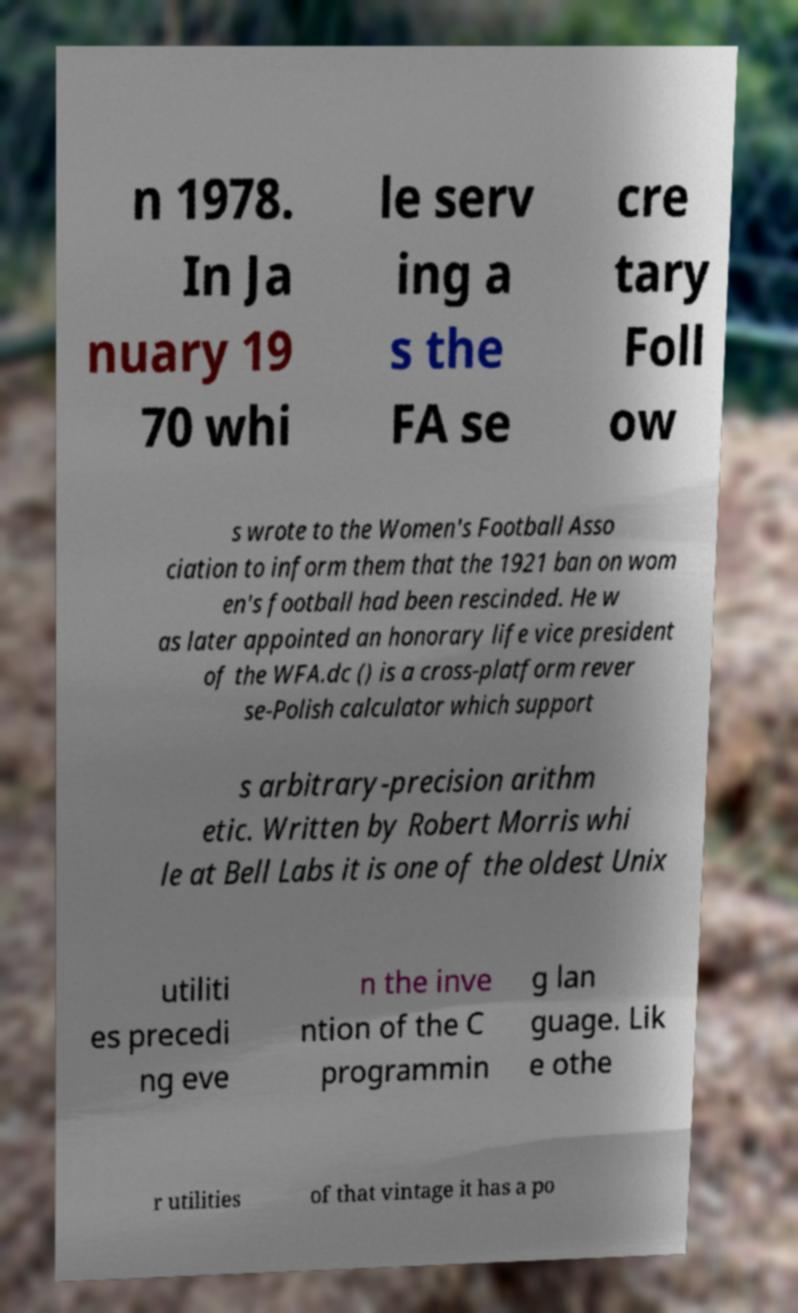Could you extract and type out the text from this image? n 1978. In Ja nuary 19 70 whi le serv ing a s the FA se cre tary Foll ow s wrote to the Women's Football Asso ciation to inform them that the 1921 ban on wom en's football had been rescinded. He w as later appointed an honorary life vice president of the WFA.dc () is a cross-platform rever se-Polish calculator which support s arbitrary-precision arithm etic. Written by Robert Morris whi le at Bell Labs it is one of the oldest Unix utiliti es precedi ng eve n the inve ntion of the C programmin g lan guage. Lik e othe r utilities of that vintage it has a po 